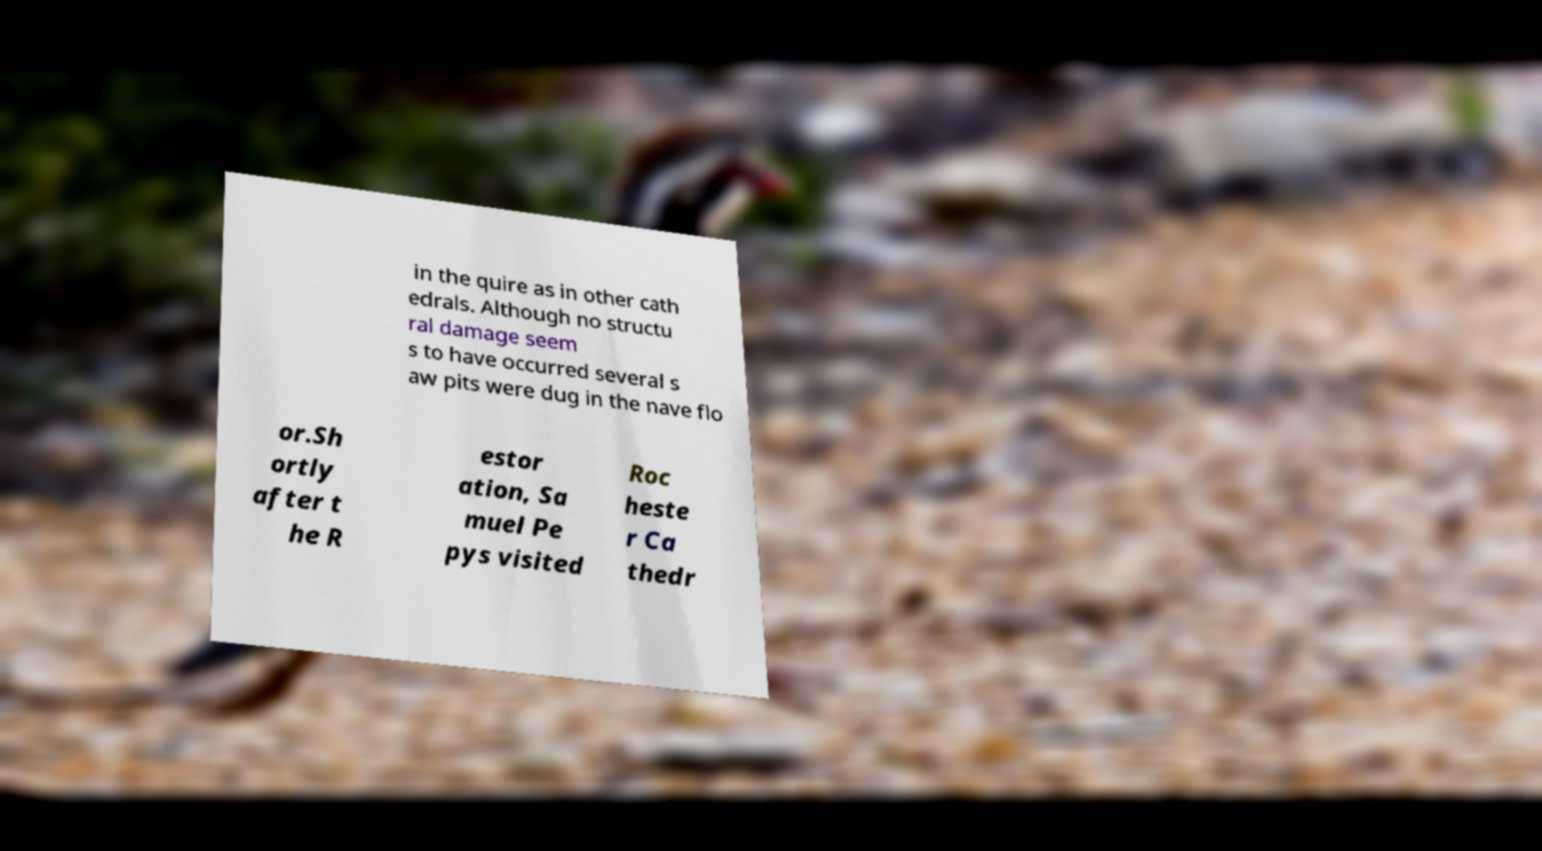What messages or text are displayed in this image? I need them in a readable, typed format. in the quire as in other cath edrals. Although no structu ral damage seem s to have occurred several s aw pits were dug in the nave flo or.Sh ortly after t he R estor ation, Sa muel Pe pys visited Roc heste r Ca thedr 